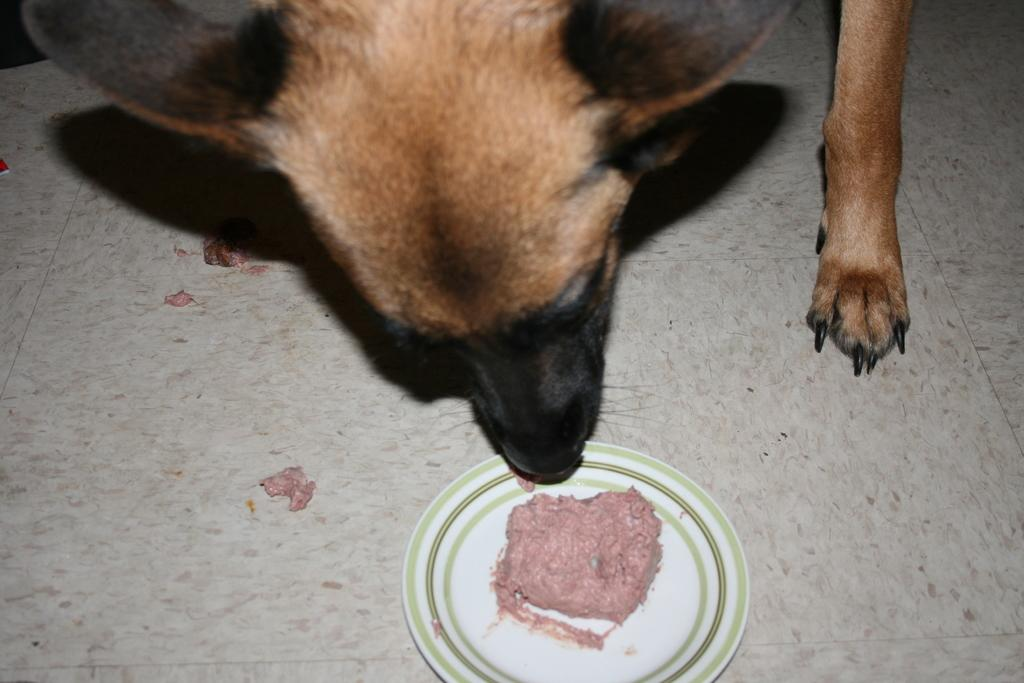What type of animal is in the image? There is a dog in the image. What is the dog doing in the image? The dog's mouth is near a plate. What is on the plate that the dog is interested in? There is a food item on the plate. Where is the plate located in the image? The plate is on the floor. What type of dock can be seen in the image? There is no dock present in the image; it features a dog near a plate on the floor. How many births are depicted in the image? There are no births depicted in the image; it features a dog near a plate on the floor. 